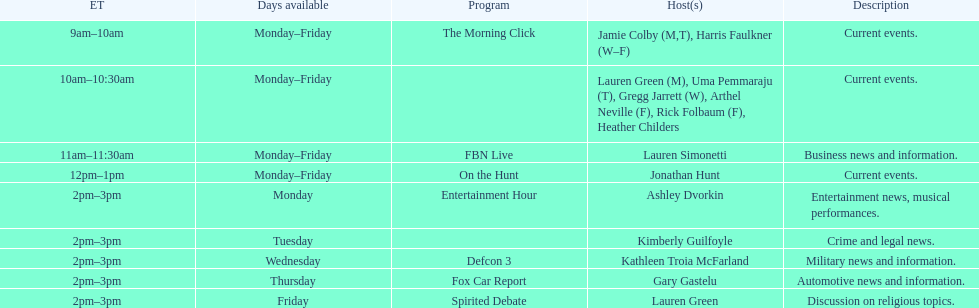Inform me the quantity of programs that exclusively feature a single presenter daily. 7. 